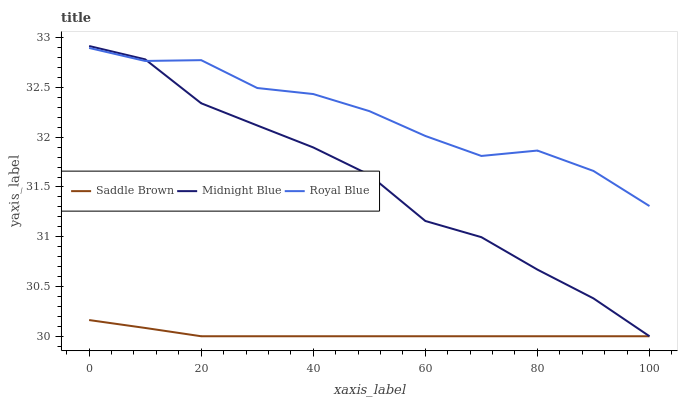Does Saddle Brown have the minimum area under the curve?
Answer yes or no. Yes. Does Royal Blue have the maximum area under the curve?
Answer yes or no. Yes. Does Midnight Blue have the minimum area under the curve?
Answer yes or no. No. Does Midnight Blue have the maximum area under the curve?
Answer yes or no. No. Is Saddle Brown the smoothest?
Answer yes or no. Yes. Is Royal Blue the roughest?
Answer yes or no. Yes. Is Midnight Blue the smoothest?
Answer yes or no. No. Is Midnight Blue the roughest?
Answer yes or no. No. Does Saddle Brown have the lowest value?
Answer yes or no. Yes. Does Midnight Blue have the highest value?
Answer yes or no. Yes. Does Saddle Brown have the highest value?
Answer yes or no. No. Is Saddle Brown less than Royal Blue?
Answer yes or no. Yes. Is Royal Blue greater than Saddle Brown?
Answer yes or no. Yes. Does Saddle Brown intersect Midnight Blue?
Answer yes or no. Yes. Is Saddle Brown less than Midnight Blue?
Answer yes or no. No. Is Saddle Brown greater than Midnight Blue?
Answer yes or no. No. Does Saddle Brown intersect Royal Blue?
Answer yes or no. No. 